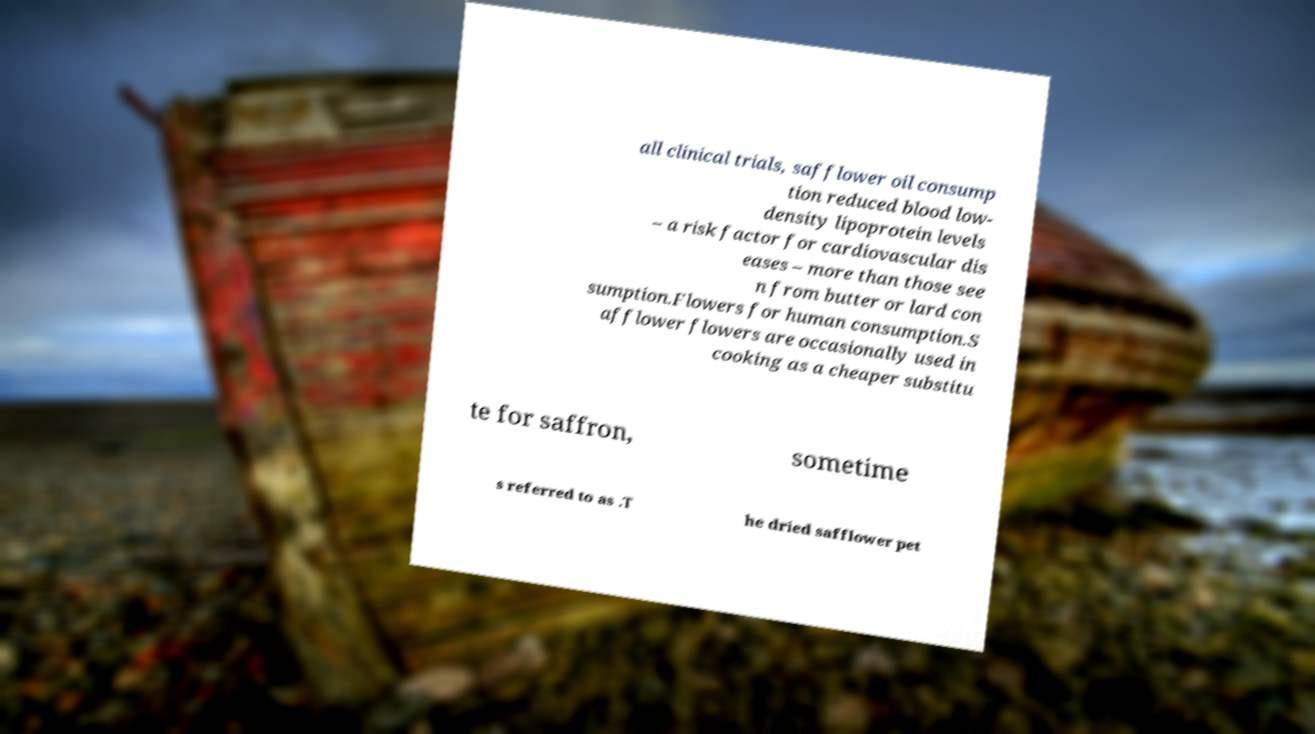There's text embedded in this image that I need extracted. Can you transcribe it verbatim? all clinical trials, safflower oil consump tion reduced blood low- density lipoprotein levels – a risk factor for cardiovascular dis eases – more than those see n from butter or lard con sumption.Flowers for human consumption.S afflower flowers are occasionally used in cooking as a cheaper substitu te for saffron, sometime s referred to as .T he dried safflower pet 